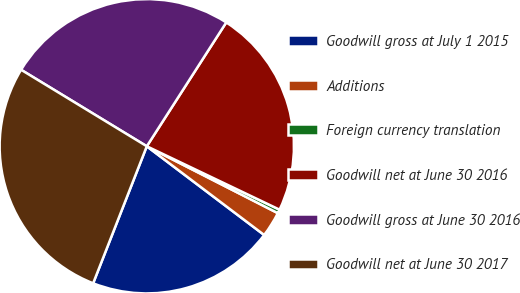Convert chart to OTSL. <chart><loc_0><loc_0><loc_500><loc_500><pie_chart><fcel>Goodwill gross at July 1 2015<fcel>Additions<fcel>Foreign currency translation<fcel>Goodwill net at June 30 2016<fcel>Goodwill gross at June 30 2016<fcel>Goodwill net at June 30 2017<nl><fcel>20.64%<fcel>2.79%<fcel>0.42%<fcel>23.01%<fcel>25.38%<fcel>27.76%<nl></chart> 